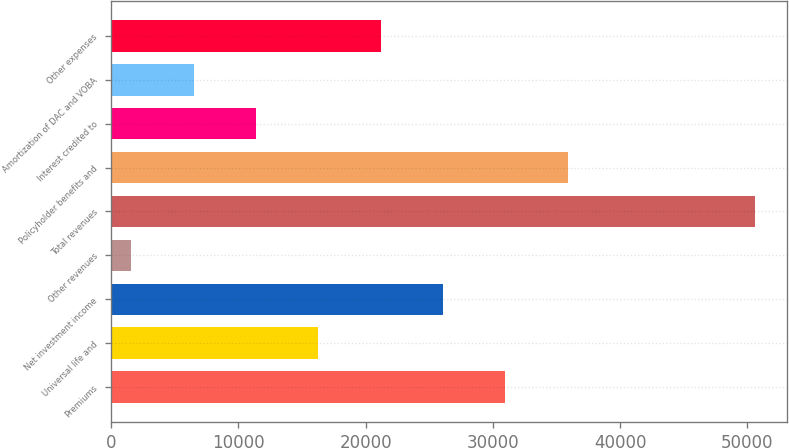Convert chart. <chart><loc_0><loc_0><loc_500><loc_500><bar_chart><fcel>Premiums<fcel>Universal life and<fcel>Net investment income<fcel>Other revenues<fcel>Total revenues<fcel>Policyholder benefits and<fcel>Interest credited to<fcel>Amortization of DAC and VOBA<fcel>Other expenses<nl><fcel>30973.6<fcel>16274.8<fcel>26074<fcel>1576<fcel>50572<fcel>35873.2<fcel>11375.2<fcel>6475.6<fcel>21174.4<nl></chart> 